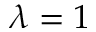Convert formula to latex. <formula><loc_0><loc_0><loc_500><loc_500>\lambda = 1</formula> 